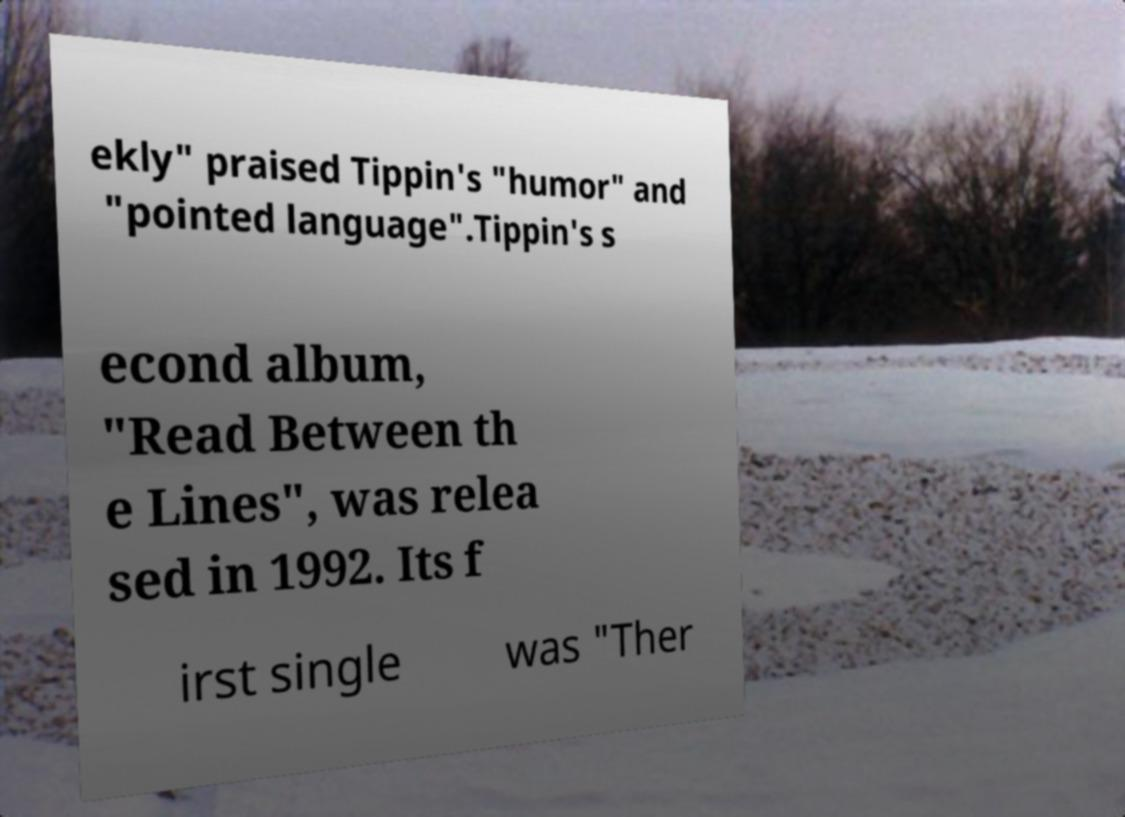Could you assist in decoding the text presented in this image and type it out clearly? ekly" praised Tippin's "humor" and "pointed language".Tippin's s econd album, "Read Between th e Lines", was relea sed in 1992. Its f irst single was "Ther 